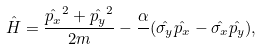<formula> <loc_0><loc_0><loc_500><loc_500>\hat { H } = \frac { \hat { p _ { x } } ^ { 2 } + \hat { p _ { y } } ^ { 2 } } { 2 m } - \frac { \alpha } { } ( \hat { \sigma _ { y } } \hat { p _ { x } } - \hat { \sigma _ { x } } \hat { p _ { y } } ) ,</formula> 